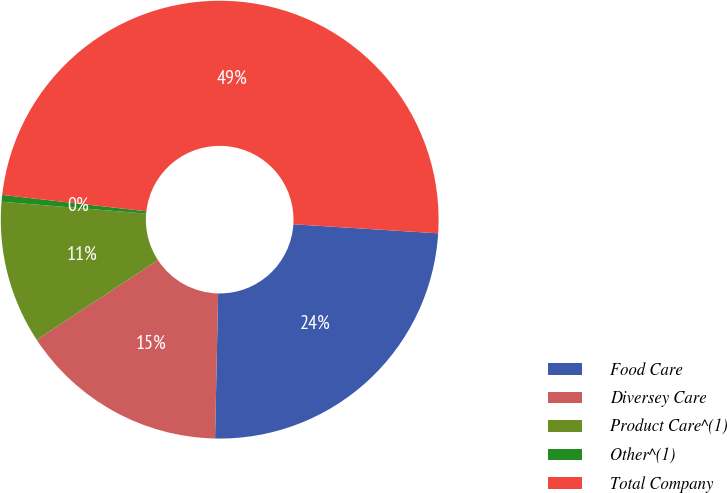<chart> <loc_0><loc_0><loc_500><loc_500><pie_chart><fcel>Food Care<fcel>Diversey Care<fcel>Product Care^(1)<fcel>Other^(1)<fcel>Total Company<nl><fcel>24.34%<fcel>15.42%<fcel>10.55%<fcel>0.5%<fcel>49.19%<nl></chart> 